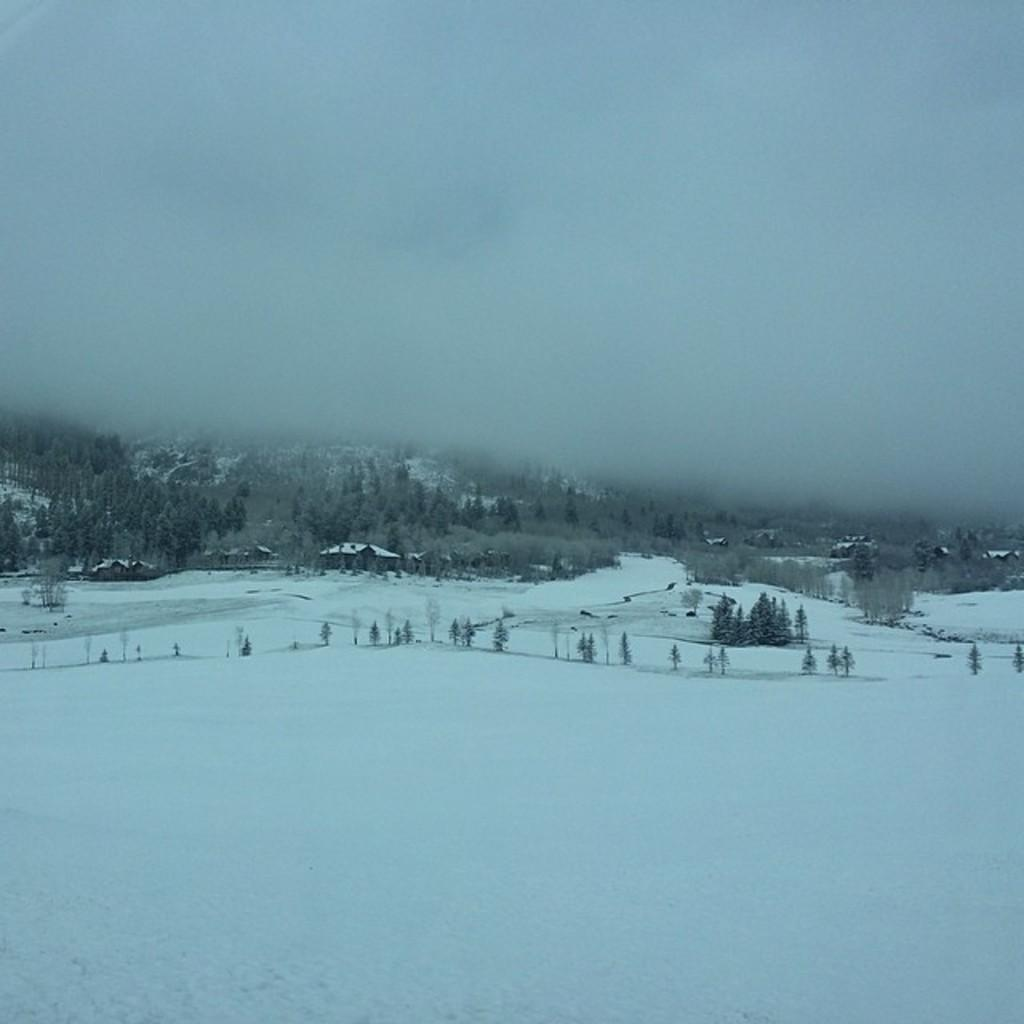What type of weather condition is depicted in the image? There is snow in the image, indicating a cold or wintry weather condition. What type of vegetation can be seen in the image? There are trees in the image. What type of structures are present in the image? There are buildings in the image. What is visible in the background of the image? The background of the image includes fog. Can you see the moon in the image? There is no moon visible in the image; it is focused on snow, trees, buildings, and fog. What type of punishment is being carried out in the image? There is no punishment being carried out in the image; it is focused on snow, trees, buildings, and fog. 